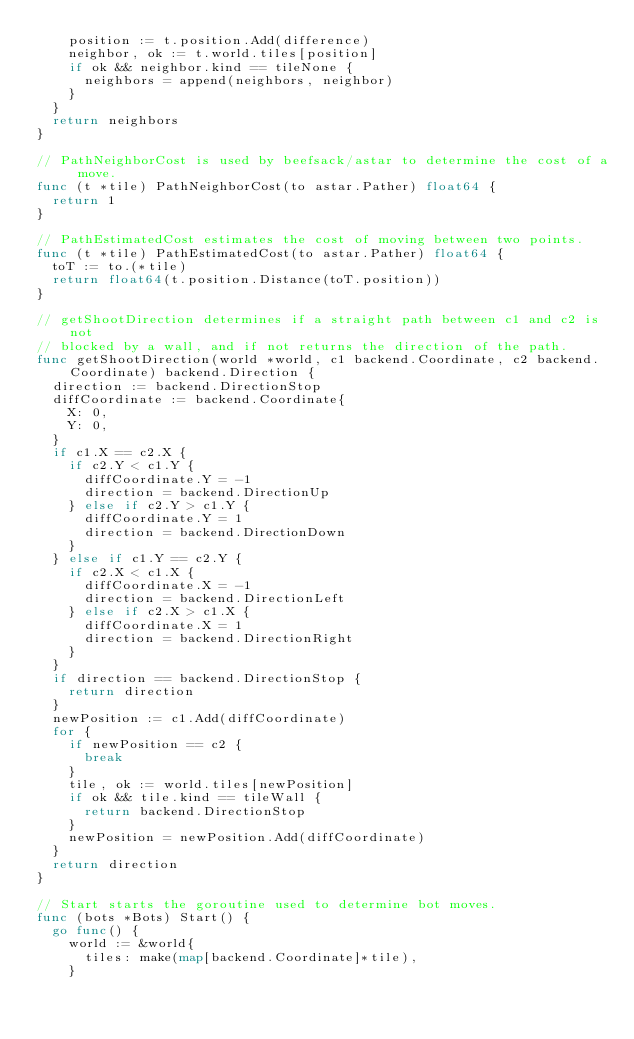Convert code to text. <code><loc_0><loc_0><loc_500><loc_500><_Go_>		position := t.position.Add(difference)
		neighbor, ok := t.world.tiles[position]
		if ok && neighbor.kind == tileNone {
			neighbors = append(neighbors, neighbor)
		}
	}
	return neighbors
}

// PathNeighborCost is used by beefsack/astar to determine the cost of a move.
func (t *tile) PathNeighborCost(to astar.Pather) float64 {
	return 1
}

// PathEstimatedCost estimates the cost of moving between two points.
func (t *tile) PathEstimatedCost(to astar.Pather) float64 {
	toT := to.(*tile)
	return float64(t.position.Distance(toT.position))
}

// getShootDirection determines if a straight path between c1 and c2 is not
// blocked by a wall, and if not returns the direction of the path.
func getShootDirection(world *world, c1 backend.Coordinate, c2 backend.Coordinate) backend.Direction {
	direction := backend.DirectionStop
	diffCoordinate := backend.Coordinate{
		X: 0,
		Y: 0,
	}
	if c1.X == c2.X {
		if c2.Y < c1.Y {
			diffCoordinate.Y = -1
			direction = backend.DirectionUp
		} else if c2.Y > c1.Y {
			diffCoordinate.Y = 1
			direction = backend.DirectionDown
		}
	} else if c1.Y == c2.Y {
		if c2.X < c1.X {
			diffCoordinate.X = -1
			direction = backend.DirectionLeft
		} else if c2.X > c1.X {
			diffCoordinate.X = 1
			direction = backend.DirectionRight
		}
	}
	if direction == backend.DirectionStop {
		return direction
	}
	newPosition := c1.Add(diffCoordinate)
	for {
		if newPosition == c2 {
			break
		}
		tile, ok := world.tiles[newPosition]
		if ok && tile.kind == tileWall {
			return backend.DirectionStop
		}
		newPosition = newPosition.Add(diffCoordinate)
	}
	return direction
}

// Start starts the goroutine used to determine bot moves.
func (bots *Bots) Start() {
	go func() {
		world := &world{
			tiles: make(map[backend.Coordinate]*tile),
		}</code> 